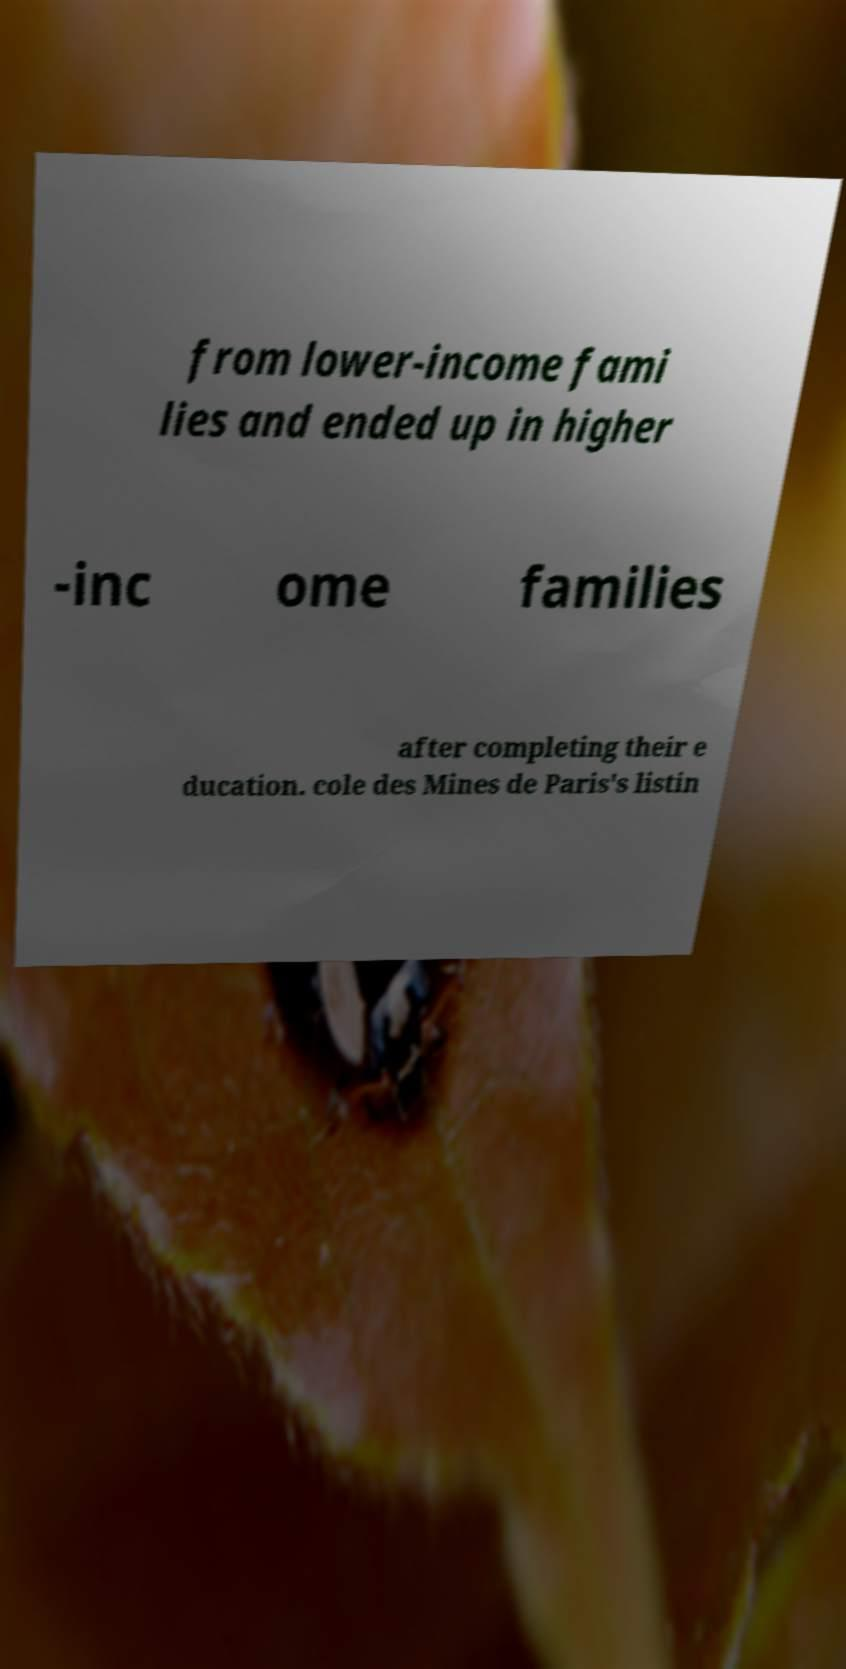Could you extract and type out the text from this image? from lower-income fami lies and ended up in higher -inc ome families after completing their e ducation. cole des Mines de Paris's listin 